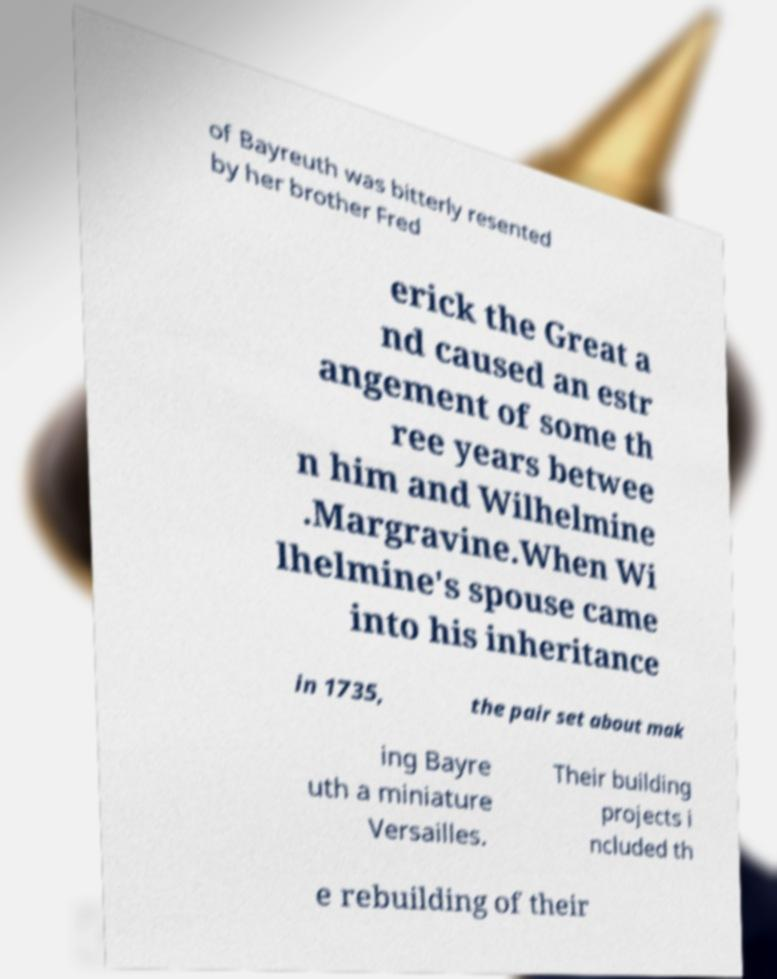Please identify and transcribe the text found in this image. of Bayreuth was bitterly resented by her brother Fred erick the Great a nd caused an estr angement of some th ree years betwee n him and Wilhelmine .Margravine.When Wi lhelmine's spouse came into his inheritance in 1735, the pair set about mak ing Bayre uth a miniature Versailles. Their building projects i ncluded th e rebuilding of their 